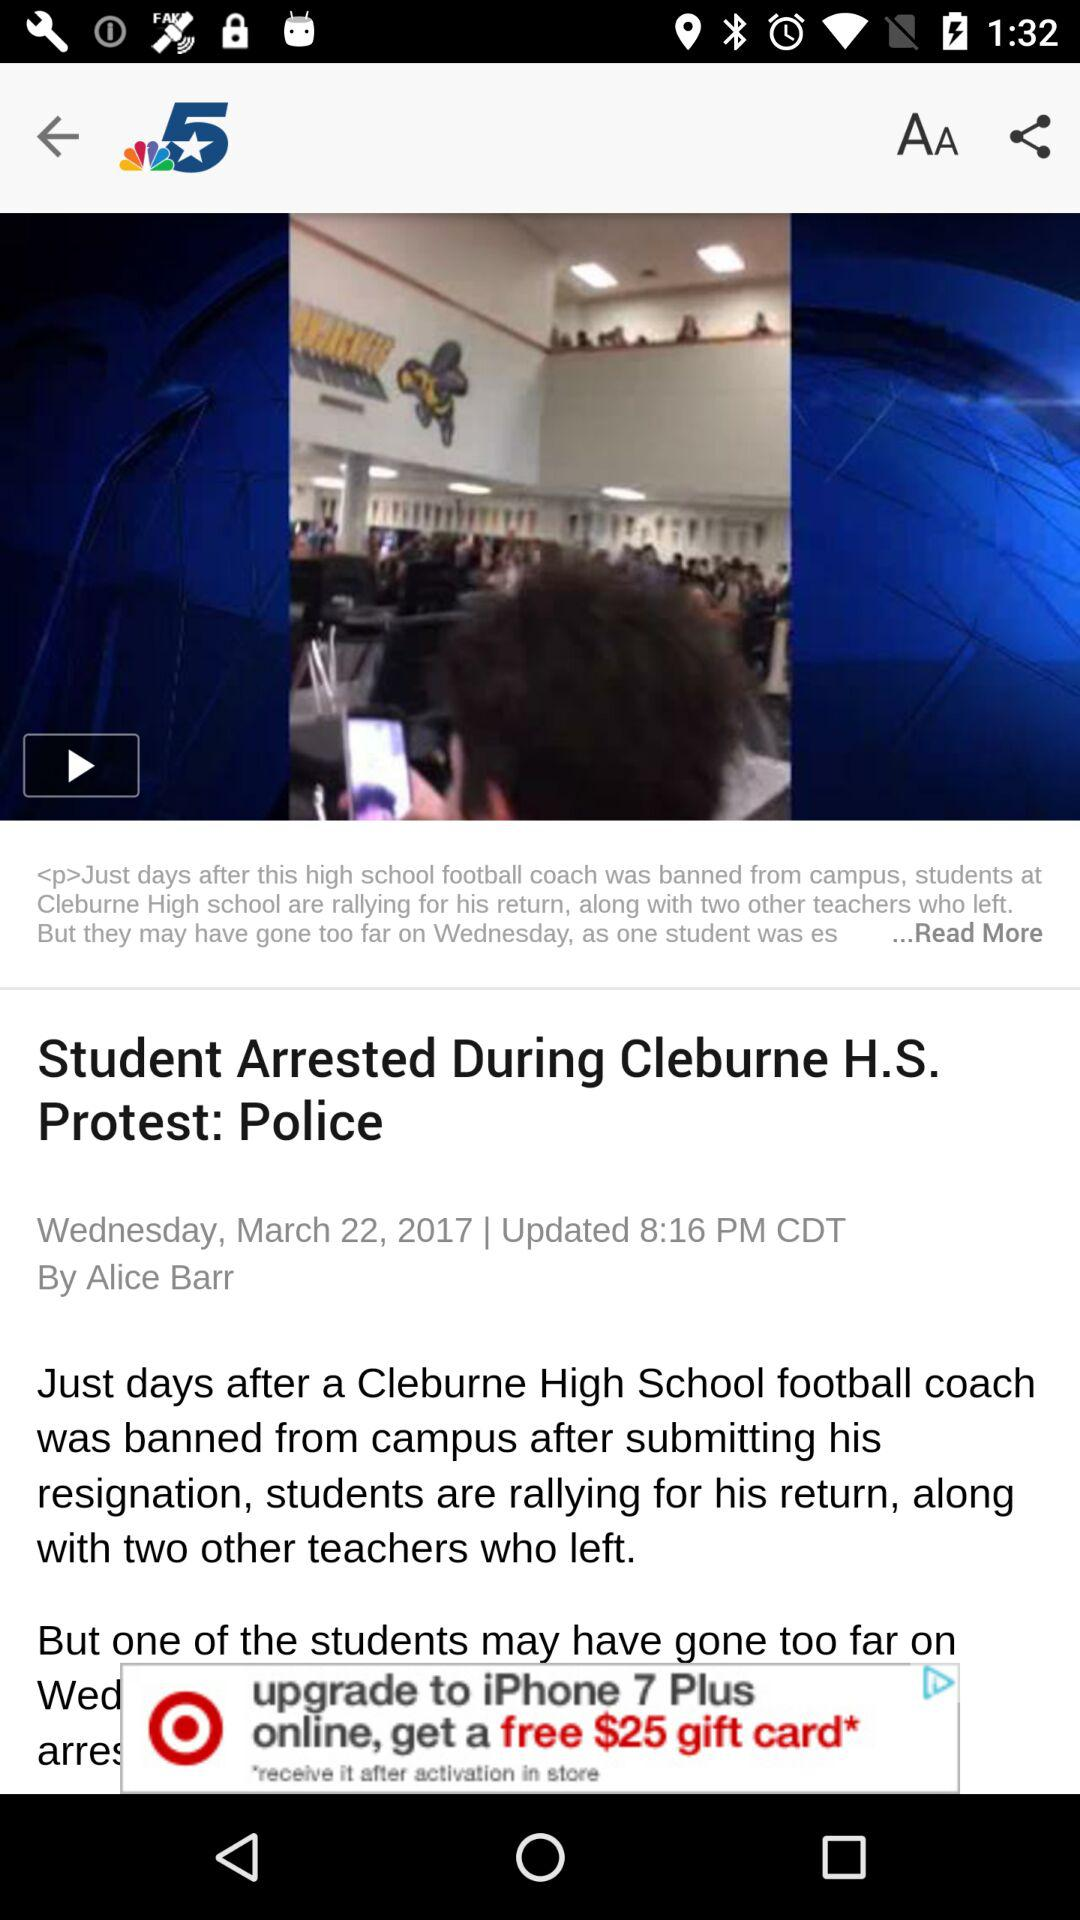On what date is the news published? The news is published on Wednesday, March 22, 2017. 